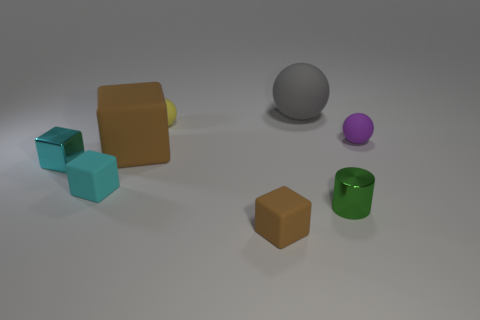Add 2 big cyan matte cylinders. How many objects exist? 10 Subtract 0 blue cylinders. How many objects are left? 8 Subtract all cylinders. How many objects are left? 7 Subtract all balls. Subtract all big red matte blocks. How many objects are left? 5 Add 7 tiny spheres. How many tiny spheres are left? 9 Add 7 tiny cylinders. How many tiny cylinders exist? 8 